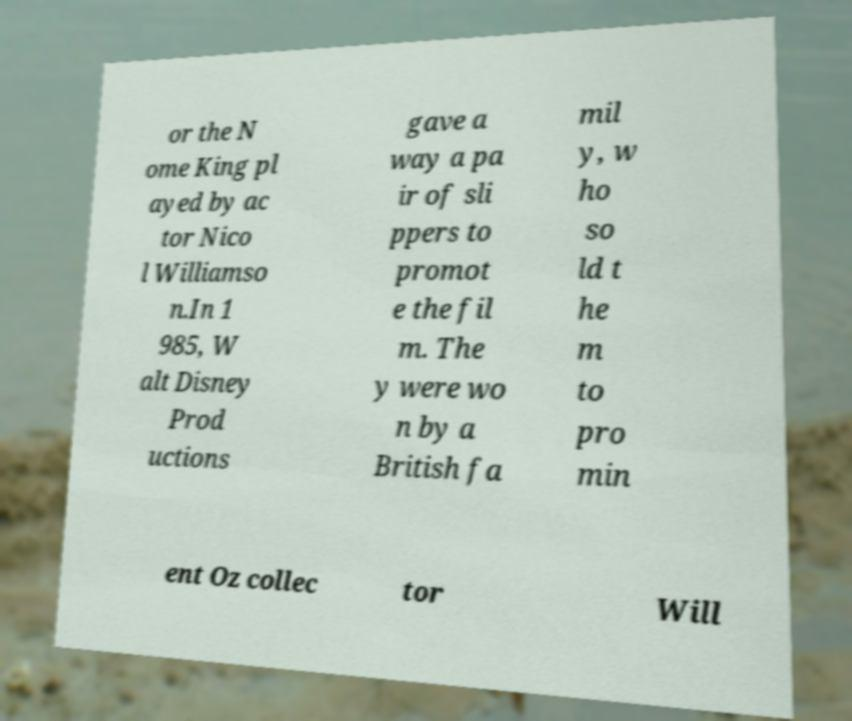For documentation purposes, I need the text within this image transcribed. Could you provide that? or the N ome King pl ayed by ac tor Nico l Williamso n.In 1 985, W alt Disney Prod uctions gave a way a pa ir of sli ppers to promot e the fil m. The y were wo n by a British fa mil y, w ho so ld t he m to pro min ent Oz collec tor Will 